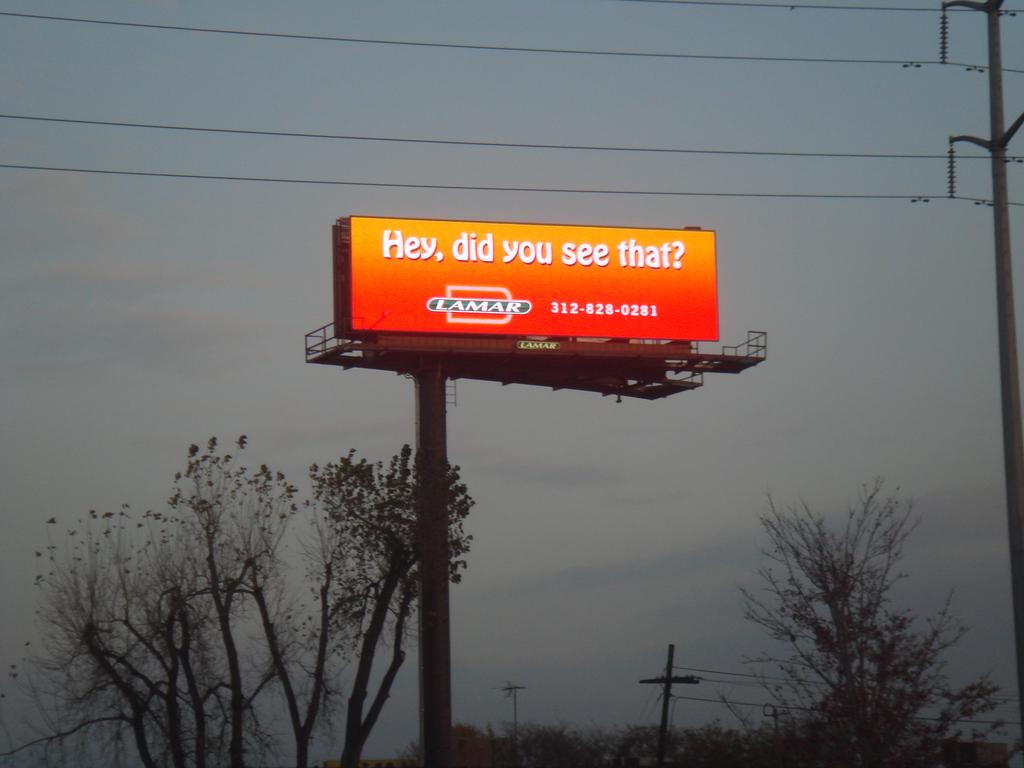What is the phone number given on this billboard?
Make the answer very short. 312-828-0281. What does the logo say?
Your answer should be very brief. Hey, did you see that?. 